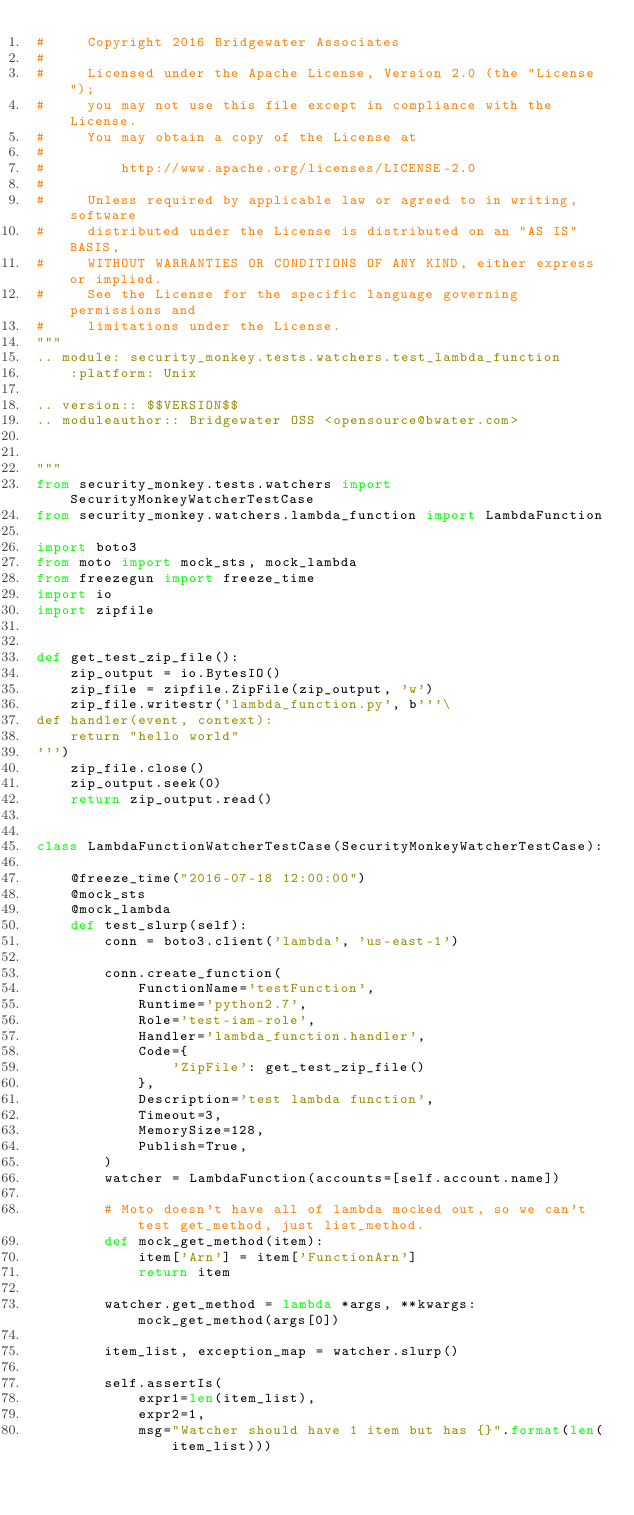Convert code to text. <code><loc_0><loc_0><loc_500><loc_500><_Python_>#     Copyright 2016 Bridgewater Associates
#
#     Licensed under the Apache License, Version 2.0 (the "License");
#     you may not use this file except in compliance with the License.
#     You may obtain a copy of the License at
#
#         http://www.apache.org/licenses/LICENSE-2.0
#
#     Unless required by applicable law or agreed to in writing, software
#     distributed under the License is distributed on an "AS IS" BASIS,
#     WITHOUT WARRANTIES OR CONDITIONS OF ANY KIND, either express or implied.
#     See the License for the specific language governing permissions and
#     limitations under the License.
"""
.. module: security_monkey.tests.watchers.test_lambda_function
    :platform: Unix

.. version:: $$VERSION$$
.. moduleauthor:: Bridgewater OSS <opensource@bwater.com>


"""
from security_monkey.tests.watchers import SecurityMonkeyWatcherTestCase
from security_monkey.watchers.lambda_function import LambdaFunction

import boto3
from moto import mock_sts, mock_lambda
from freezegun import freeze_time
import io
import zipfile


def get_test_zip_file():
    zip_output = io.BytesIO()
    zip_file = zipfile.ZipFile(zip_output, 'w')
    zip_file.writestr('lambda_function.py', b'''\
def handler(event, context):
    return "hello world"
''')
    zip_file.close()
    zip_output.seek(0)
    return zip_output.read()


class LambdaFunctionWatcherTestCase(SecurityMonkeyWatcherTestCase):

    @freeze_time("2016-07-18 12:00:00")
    @mock_sts
    @mock_lambda
    def test_slurp(self):
        conn = boto3.client('lambda', 'us-east-1')

        conn.create_function(
            FunctionName='testFunction',
            Runtime='python2.7',
            Role='test-iam-role',
            Handler='lambda_function.handler',
            Code={
                'ZipFile': get_test_zip_file()
            },
            Description='test lambda function',
            Timeout=3,
            MemorySize=128,
            Publish=True,
        )
        watcher = LambdaFunction(accounts=[self.account.name])

        # Moto doesn't have all of lambda mocked out, so we can't test get_method, just list_method.
        def mock_get_method(item):
            item['Arn'] = item['FunctionArn']
            return item

        watcher.get_method = lambda *args, **kwargs: mock_get_method(args[0])

        item_list, exception_map = watcher.slurp()

        self.assertIs(
            expr1=len(item_list),
            expr2=1,
            msg="Watcher should have 1 item but has {}".format(len(item_list)))
</code> 